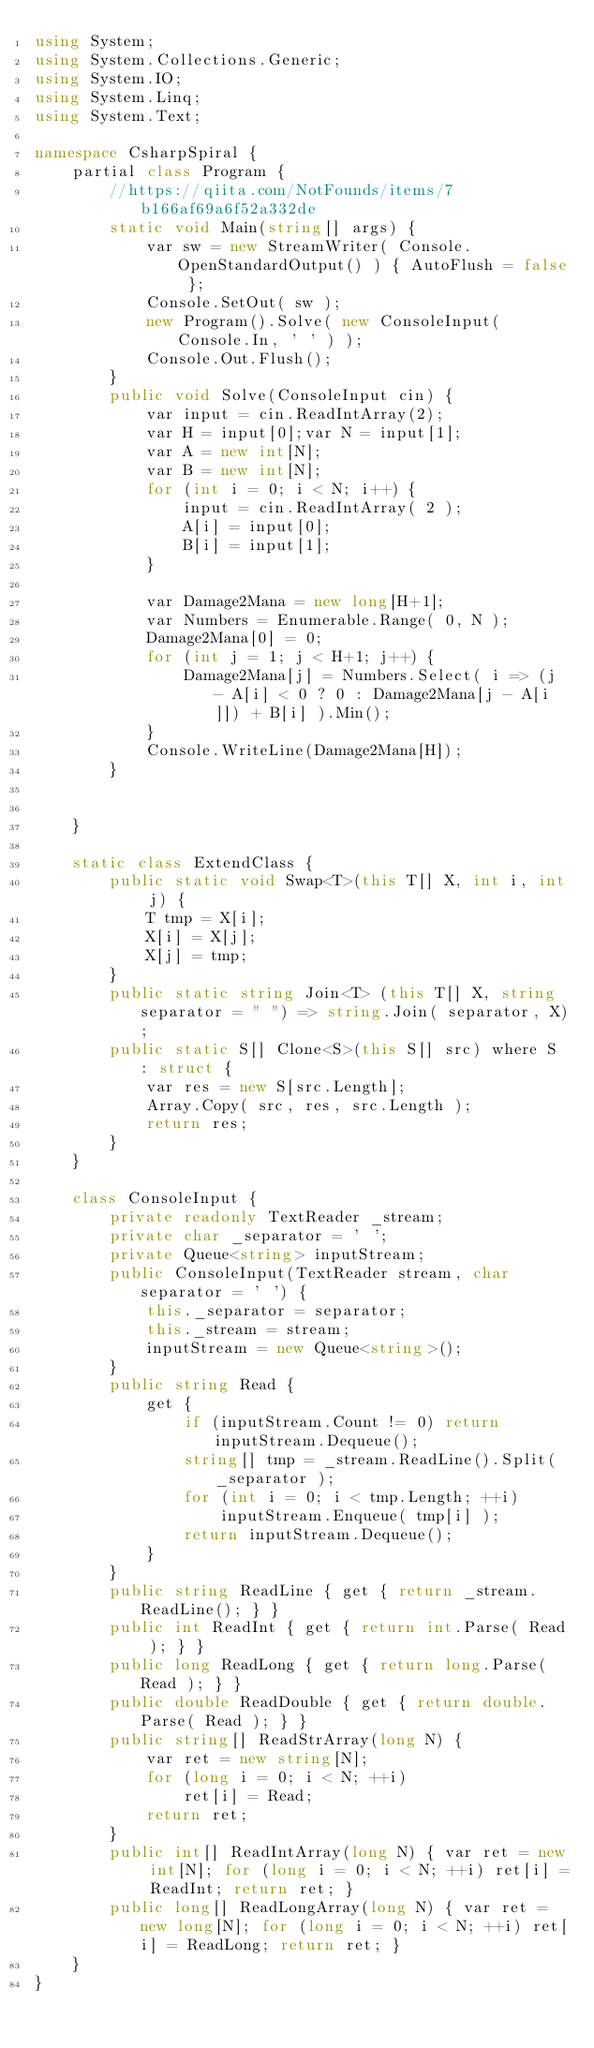Convert code to text. <code><loc_0><loc_0><loc_500><loc_500><_C#_>using System;
using System.Collections.Generic;
using System.IO;
using System.Linq;
using System.Text;

namespace CsharpSpiral {
    partial class Program {
        //https://qiita.com/NotFounds/items/7b166af69a6f52a332de
        static void Main(string[] args) {
            var sw = new StreamWriter( Console.OpenStandardOutput() ) { AutoFlush = false };
            Console.SetOut( sw );
            new Program().Solve( new ConsoleInput( Console.In, ' ' ) );
            Console.Out.Flush();
        }
        public void Solve(ConsoleInput cin) {
            var input = cin.ReadIntArray(2);
            var H = input[0];var N = input[1];
            var A = new int[N];
            var B = new int[N];
            for (int i = 0; i < N; i++) {
                input = cin.ReadIntArray( 2 );
                A[i] = input[0];
                B[i] = input[1];
            }

            var Damage2Mana = new long[H+1];
            var Numbers = Enumerable.Range( 0, N );
            Damage2Mana[0] = 0;
            for (int j = 1; j < H+1; j++) {
                Damage2Mana[j] = Numbers.Select( i => (j - A[i] < 0 ? 0 : Damage2Mana[j - A[i]]) + B[i] ).Min();
            }
            Console.WriteLine(Damage2Mana[H]);
        }

        
    }

    static class ExtendClass {
        public static void Swap<T>(this T[] X, int i, int j) {
            T tmp = X[i];
            X[i] = X[j];
            X[j] = tmp;
        }
        public static string Join<T> (this T[] X, string separator = " ") => string.Join( separator, X);
        public static S[] Clone<S>(this S[] src) where S : struct {
            var res = new S[src.Length];
            Array.Copy( src, res, src.Length );
            return res;
        }
    }

    class ConsoleInput {
        private readonly TextReader _stream;
        private char _separator = ' ';
        private Queue<string> inputStream;
        public ConsoleInput(TextReader stream, char separator = ' ') {
            this._separator = separator;
            this._stream = stream;
            inputStream = new Queue<string>();
        }
        public string Read {
            get {
                if (inputStream.Count != 0) return inputStream.Dequeue();
                string[] tmp = _stream.ReadLine().Split( _separator );
                for (int i = 0; i < tmp.Length; ++i)
                    inputStream.Enqueue( tmp[i] );
                return inputStream.Dequeue();
            }
        }
        public string ReadLine { get { return _stream.ReadLine(); } }
        public int ReadInt { get { return int.Parse( Read ); } }
        public long ReadLong { get { return long.Parse( Read ); } }
        public double ReadDouble { get { return double.Parse( Read ); } }
        public string[] ReadStrArray(long N) {
            var ret = new string[N];
            for (long i = 0; i < N; ++i)
                ret[i] = Read;
            return ret;
        }
        public int[] ReadIntArray(long N) { var ret = new int[N]; for (long i = 0; i < N; ++i) ret[i] = ReadInt; return ret; }
        public long[] ReadLongArray(long N) { var ret = new long[N]; for (long i = 0; i < N; ++i) ret[i] = ReadLong; return ret; }
    }
}
</code> 